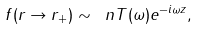Convert formula to latex. <formula><loc_0><loc_0><loc_500><loc_500>f ( r \rightarrow r _ { + } ) \sim { \ n T } ( \omega ) e ^ { - i \omega z } ,</formula> 